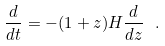Convert formula to latex. <formula><loc_0><loc_0><loc_500><loc_500>\frac { d } { d t } = - ( 1 + z ) H \frac { d } { d z } \ .</formula> 